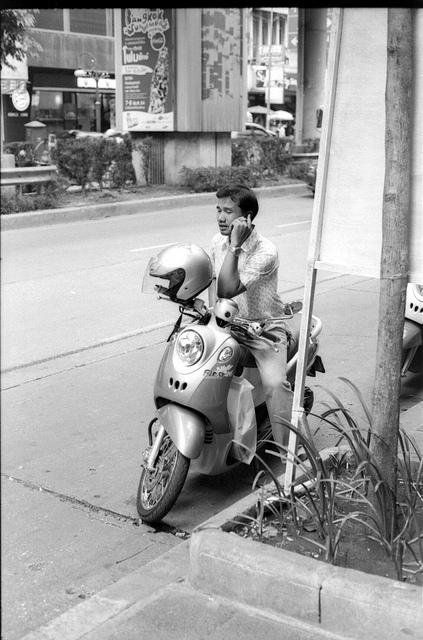What has the man stopped on his scooter? phone call 